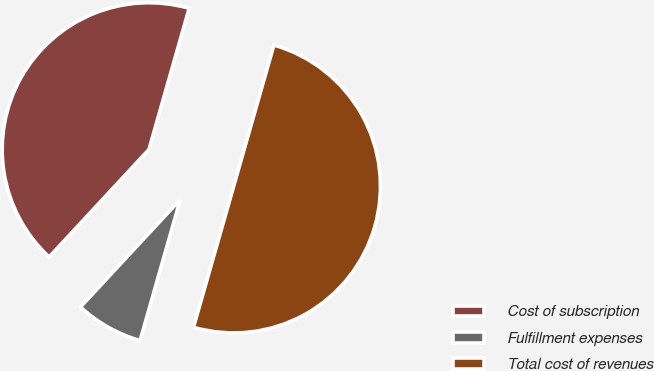Convert chart to OTSL. <chart><loc_0><loc_0><loc_500><loc_500><pie_chart><fcel>Cost of subscription<fcel>Fulfillment expenses<fcel>Total cost of revenues<nl><fcel>42.51%<fcel>7.49%<fcel>50.0%<nl></chart> 